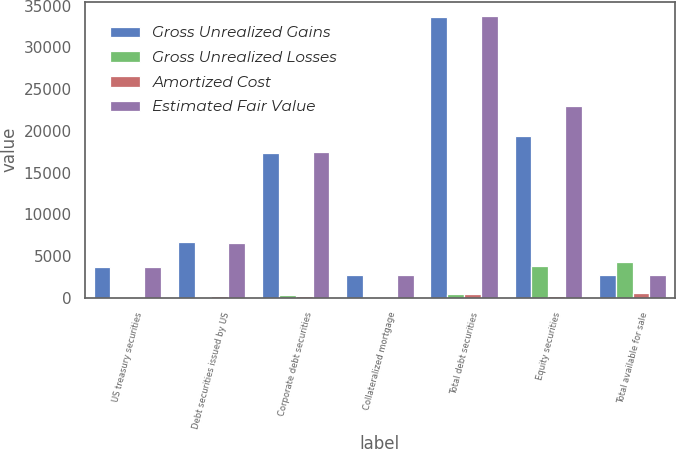Convert chart. <chart><loc_0><loc_0><loc_500><loc_500><stacked_bar_chart><ecel><fcel>US treasury securities<fcel>Debt securities issued by US<fcel>Corporate debt securities<fcel>Collateralized mortgage<fcel>Total debt securities<fcel>Equity securities<fcel>Total available for sale<nl><fcel>Gross Unrealized Gains<fcel>3679<fcel>6654<fcel>17347<fcel>2671<fcel>33687<fcel>19405<fcel>2695.5<nl><fcel>Gross Unrealized Losses<fcel>20<fcel>29<fcel>341<fcel>53<fcel>488<fcel>3821<fcel>4309<nl><fcel>Amortized Cost<fcel>11<fcel>155<fcel>232<fcel>4<fcel>402<fcel>199<fcel>601<nl><fcel>Estimated Fair Value<fcel>3688<fcel>6528<fcel>17456<fcel>2720<fcel>33773<fcel>23027<fcel>2695.5<nl></chart> 